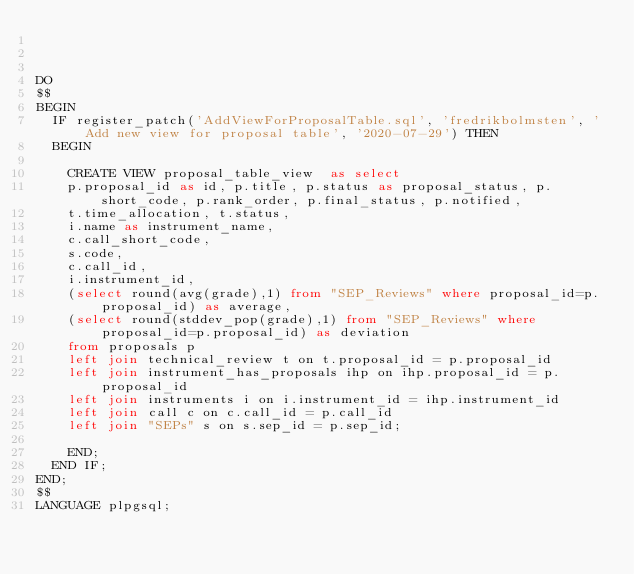<code> <loc_0><loc_0><loc_500><loc_500><_SQL_>


DO
$$
BEGIN
	IF register_patch('AddViewForProposalTable.sql', 'fredrikbolmsten', 'Add new view for proposal table', '2020-07-29') THEN
	BEGIN

    CREATE VIEW proposal_table_view  as select 
    p.proposal_id as id, p.title, p.status as proposal_status, p.short_code, p.rank_order, p.final_status, p.notified, 
    t.time_allocation, t.status,
    i.name as instrument_name,
    c.call_short_code,
    s.code,
    c.call_id,
    i.instrument_id,
    (select round(avg(grade),1) from "SEP_Reviews" where proposal_id=p.proposal_id) as average,
    (select round(stddev_pop(grade),1) from "SEP_Reviews" where proposal_id=p.proposal_id) as deviation
    from proposals p 
    left join technical_review t on t.proposal_id = p.proposal_id
    left join instrument_has_proposals ihp on ihp.proposal_id = p.proposal_id 
    left join instruments i on i.instrument_id = ihp.instrument_id
    left join call c on c.call_id = p.call_id
    left join "SEPs" s on s.sep_id = p.sep_id;

    END;
	END IF;
END;
$$
LANGUAGE plpgsql;</code> 